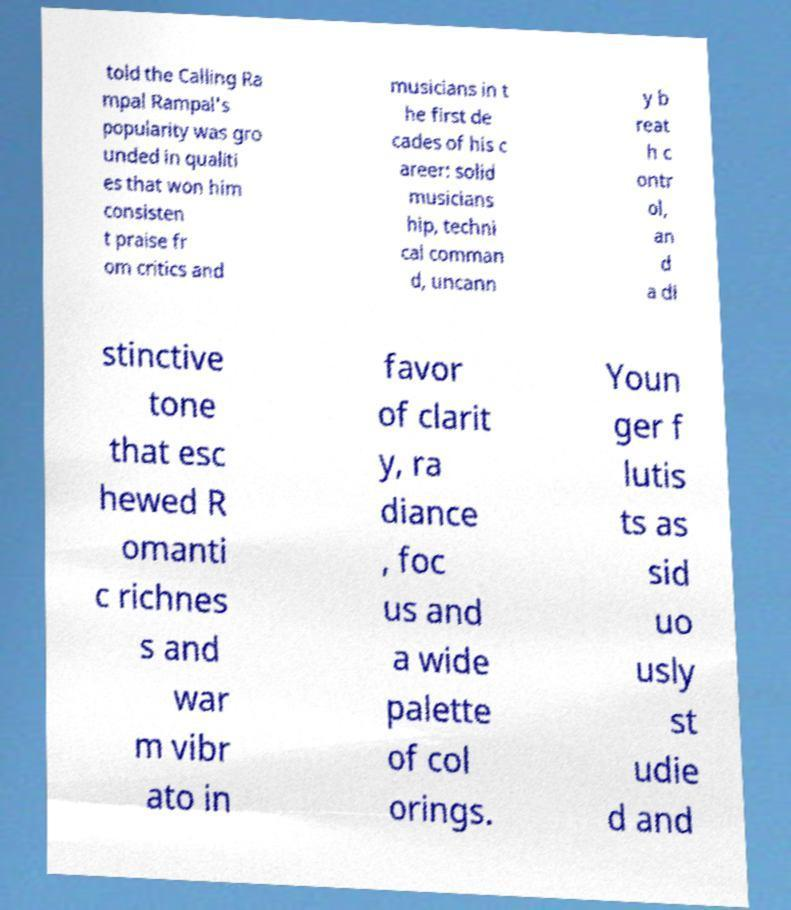There's text embedded in this image that I need extracted. Can you transcribe it verbatim? told the Calling Ra mpal Rampal's popularity was gro unded in qualiti es that won him consisten t praise fr om critics and musicians in t he first de cades of his c areer: solid musicians hip, techni cal comman d, uncann y b reat h c ontr ol, an d a di stinctive tone that esc hewed R omanti c richnes s and war m vibr ato in favor of clarit y, ra diance , foc us and a wide palette of col orings. Youn ger f lutis ts as sid uo usly st udie d and 